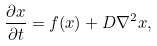<formula> <loc_0><loc_0><loc_500><loc_500>\frac { \partial x } { \partial t } = f ( x ) + D \nabla ^ { 2 } x ,</formula> 